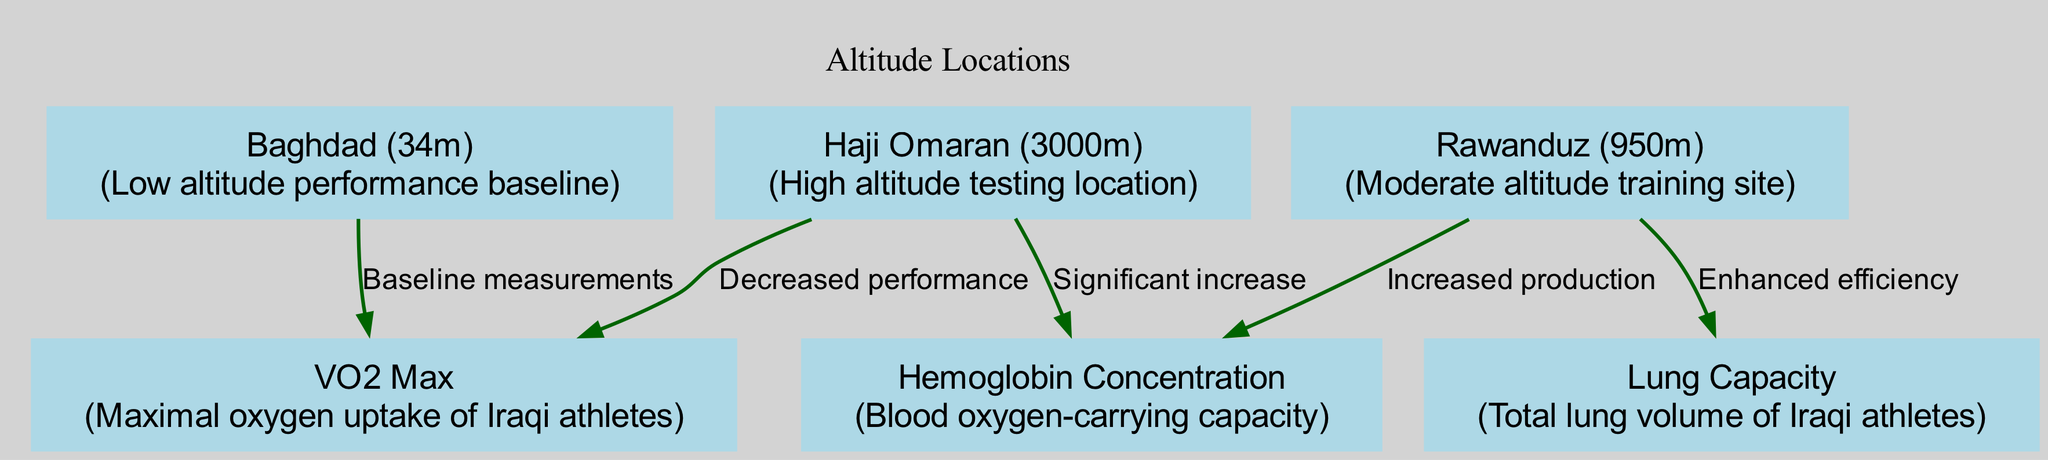What is the maximal oxygen uptake of Iraqi athletes at baseline? The node labeled "VO2 Max" connects with the "Baghdad (34m)" node indicating it represents baseline measurements. The diagram does not specify a numerical value for VO2 Max at this altitude.
Answer: Not specified What altitude does "Haji Omaran" represent? The node labeled "Haji Omaran" includes the description "High altitude testing location", indicating it is a location at 3000 meters above sea level.
Answer: 3000 meters How does hemoglobin concentration change at "Rawanduz" altitude? The edge from "Rawanduz (950m)" to "Hemoglobin Concentration" indicates increased production, meaning that hemoglobin concentration improves at this altitude.
Answer: Increased production What is the relationship between "Haji Omaran" and VO2 Max? There is an edge from "Haji Omaran (3000m)" to "VO2 Max," labeled "Decreased performance," indicating that at this high altitude, VO2 Max decreases in Iraqi athletes.
Answer: Decreased performance How many nodes are in the diagram? The total number of nodes is counted, which are six in total: VO2 Max, Hemoglobin Concentration, Lung Capacity, Baghdad, Rawanduz, and Haji Omaran.
Answer: Six nodes What impact does "Rawanduz" have on lung capacity? The edge connecting "Rawanduz (950m)" to "Lung Capacity" states "Enhanced efficiency," indicating that lung capacity improves or becomes more efficient at this altitude.
Answer: Enhanced efficiency What is the baseline location used in the diagram? The node "Baghdad (34m)" is identified as the baseline for performance measurements in the diagram, which serves as the low-altitude reference point.
Answer: Baghdad What factor significantly increases at "Haji Omaran"? The edge from "Haji Omaran (3000m)" to "Hemoglobin Concentration" is labeled "Significant increase," indicating a notable rise in hemoglobin concentration at this high-altitude location.
Answer: Significant increase What is the total lung volume of Iraqi athletes represented by? The node "Lung Capacity" reflects the total lung volume specifically for Iraqi athletes within the diagram and is influenced by various altitude training conditions.
Answer: Lung Capacity 